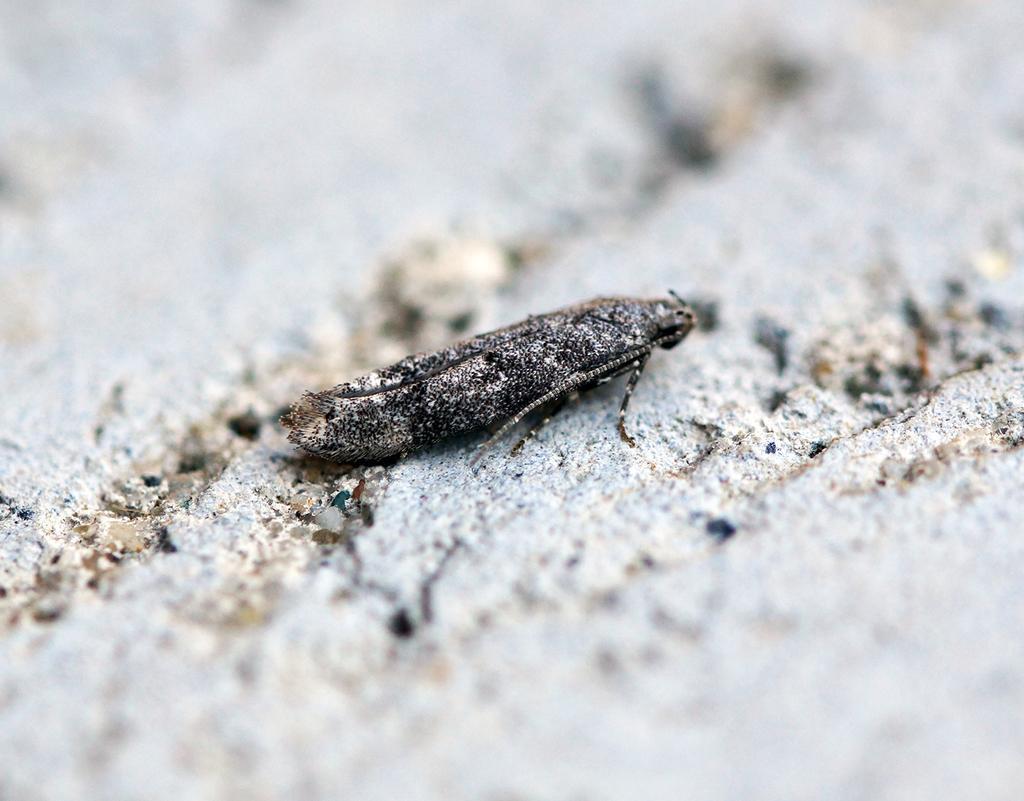Please provide a concise description of this image. Here there is an insect. 